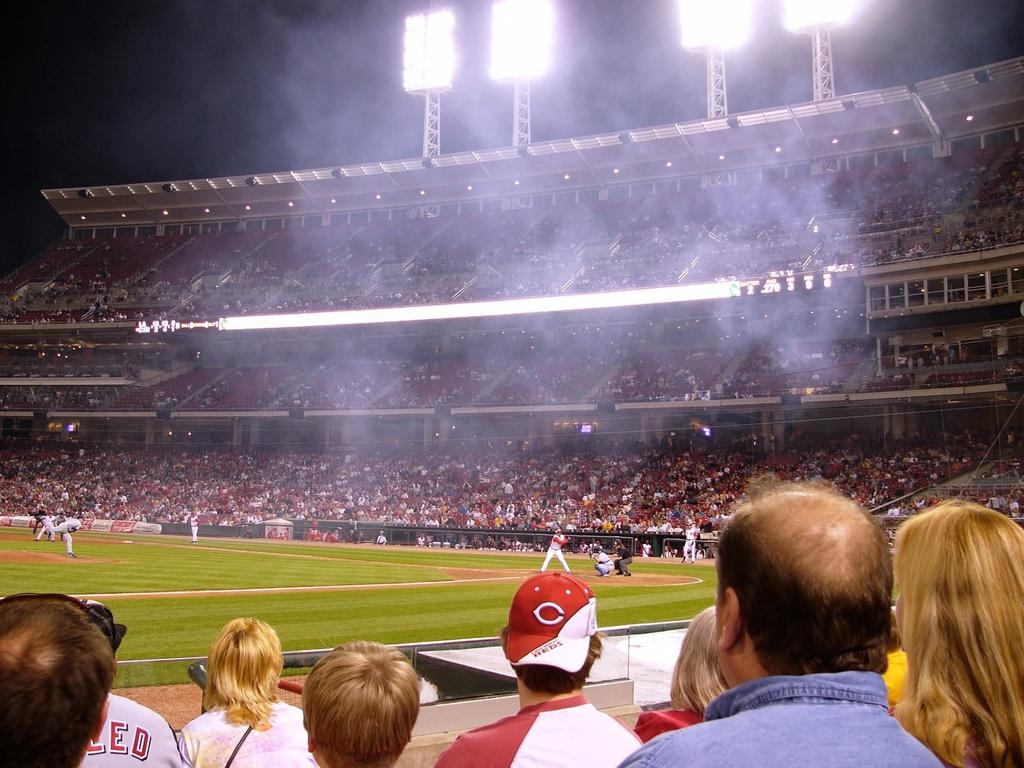What type of structure is shown in the image? There is a stadium in the image. Can you describe the people in the image? There is a group of people in the image. What can be seen illuminating the area in the image? Lights are visible in the image. What type of equipment is present in the image? Lighting trusses are present in the image. How would you describe the overall appearance of the image? There is a dark background in the image. What type of oil can be seen flowing through the railway in the image? There is no railway or oil present in the image; it features a stadium with a group of people and lighting equipment. 